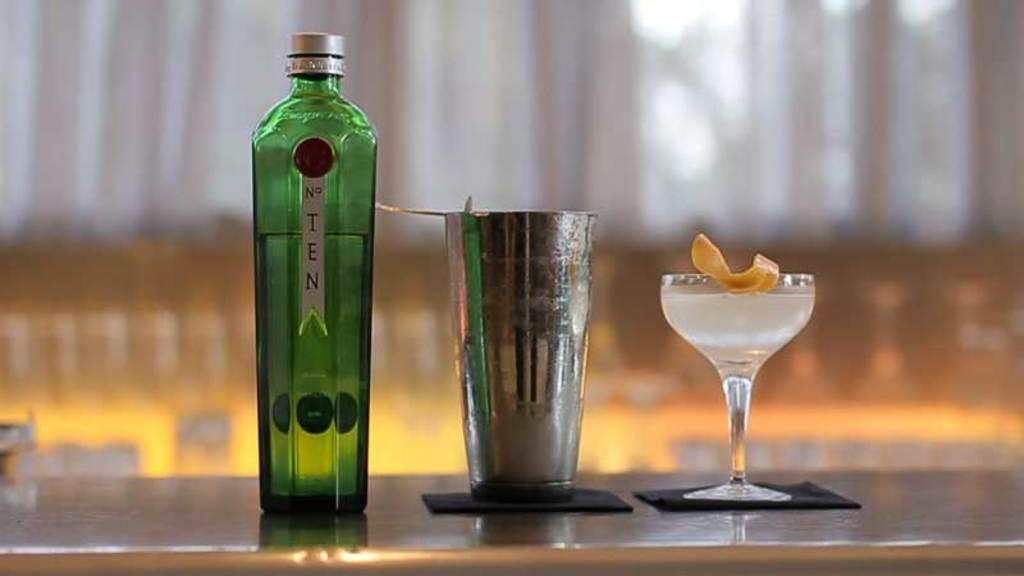<image>
Relay a brief, clear account of the picture shown. A tall bottle of No. Ten sits next to a martini shaker and a filled cocktail glass. 